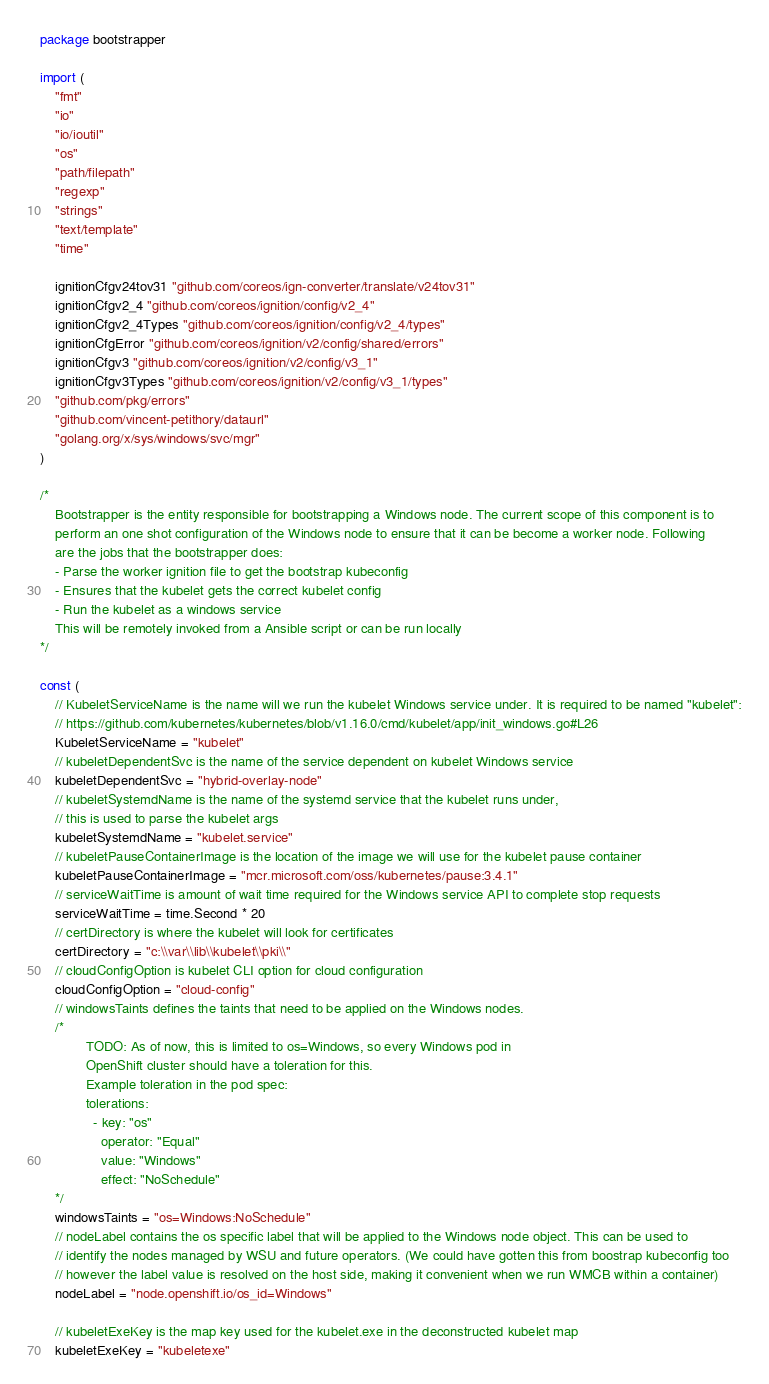<code> <loc_0><loc_0><loc_500><loc_500><_Go_>package bootstrapper

import (
	"fmt"
	"io"
	"io/ioutil"
	"os"
	"path/filepath"
	"regexp"
	"strings"
	"text/template"
	"time"

	ignitionCfgv24tov31 "github.com/coreos/ign-converter/translate/v24tov31"
	ignitionCfgv2_4 "github.com/coreos/ignition/config/v2_4"
	ignitionCfgv2_4Types "github.com/coreos/ignition/config/v2_4/types"
	ignitionCfgError "github.com/coreos/ignition/v2/config/shared/errors"
	ignitionCfgv3 "github.com/coreos/ignition/v2/config/v3_1"
	ignitionCfgv3Types "github.com/coreos/ignition/v2/config/v3_1/types"
	"github.com/pkg/errors"
	"github.com/vincent-petithory/dataurl"
	"golang.org/x/sys/windows/svc/mgr"
)

/*
	Bootstrapper is the entity responsible for bootstrapping a Windows node. The current scope of this component is to
 	perform an one shot configuration of the Windows node to ensure that it can be become a worker node. Following
    are the jobs that the bootstrapper does:
	- Parse the worker ignition file to get the bootstrap kubeconfig
	- Ensures that the kubelet gets the correct kubelet config
	- Run the kubelet as a windows service
	This will be remotely invoked from a Ansible script or can be run locally
*/

const (
	// KubeletServiceName is the name will we run the kubelet Windows service under. It is required to be named "kubelet":
	// https://github.com/kubernetes/kubernetes/blob/v1.16.0/cmd/kubelet/app/init_windows.go#L26
	KubeletServiceName = "kubelet"
	// kubeletDependentSvc is the name of the service dependent on kubelet Windows service
	kubeletDependentSvc = "hybrid-overlay-node"
	// kubeletSystemdName is the name of the systemd service that the kubelet runs under,
	// this is used to parse the kubelet args
	kubeletSystemdName = "kubelet.service"
	// kubeletPauseContainerImage is the location of the image we will use for the kubelet pause container
	kubeletPauseContainerImage = "mcr.microsoft.com/oss/kubernetes/pause:3.4.1"
	// serviceWaitTime is amount of wait time required for the Windows service API to complete stop requests
	serviceWaitTime = time.Second * 20
	// certDirectory is where the kubelet will look for certificates
	certDirectory = "c:\\var\\lib\\kubelet\\pki\\"
	// cloudConfigOption is kubelet CLI option for cloud configuration
	cloudConfigOption = "cloud-config"
	// windowsTaints defines the taints that need to be applied on the Windows nodes.
	/*
			TODO: As of now, this is limited to os=Windows, so every Windows pod in
			OpenShift cluster should have a toleration for this.
			Example toleration in the pod spec:
			tolerations:
			  - key: "os"
		      	operator: "Equal"
		      	value: "Windows"
		      	effect: "NoSchedule"
	*/
	windowsTaints = "os=Windows:NoSchedule"
	// nodeLabel contains the os specific label that will be applied to the Windows node object. This can be used to
	// identify the nodes managed by WSU and future operators. (We could have gotten this from boostrap kubeconfig too
	// however the label value is resolved on the host side, making it convenient when we run WMCB within a container)
	nodeLabel = "node.openshift.io/os_id=Windows"

	// kubeletExeKey is the map key used for the kubelet.exe in the deconstructed kubelet map
	kubeletExeKey = "kubeletexe"</code> 